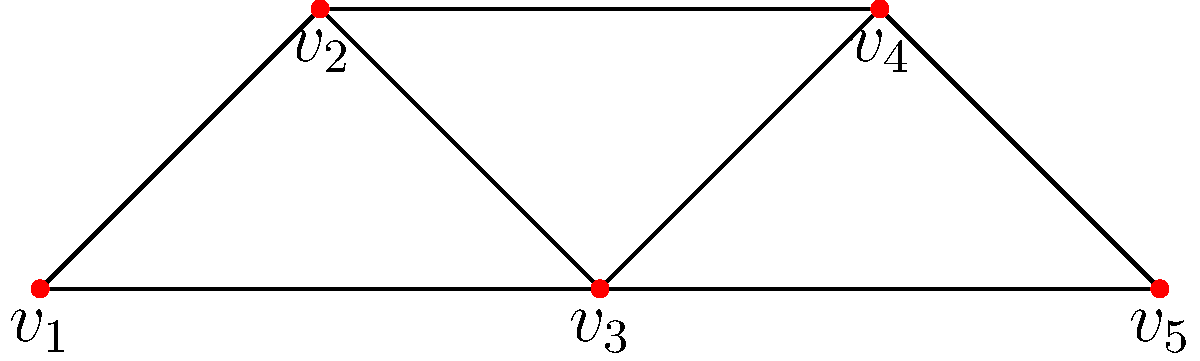Given the graph shown above, what is the minimum number of colors needed to color the vertices such that no two adjacent vertices have the same color? Provide your answer and explain the coloring strategy. To solve this problem, we'll use the greedy coloring algorithm:

1) Start with vertex $v_1$. Assign it color 1.

2) Move to $v_2$. It's adjacent to $v_1$, so we need a new color. Assign it color 2.

3) For $v_3$:
   - It's adjacent to $v_1$ (color 1) and $v_2$ (color 2).
   - We need a new color. Assign it color 3.

4) For $v_4$:
   - It's adjacent to $v_2$ (color 2) and $v_3$ (color 3).
   - We can use color 1.

5) For $v_5$:
   - It's adjacent to $v_3$ (color 3) and $v_4$ (color 1).
   - We can use color 2.

Therefore, we've colored the graph using 3 colors:
- Color 1: $v_1$, $v_4$
- Color 2: $v_2$, $v_5$
- Color 3: $v_3$

This is the minimum number of colors needed because the graph contains a triangle ($v_1$, $v_2$, $v_3$), which requires at least 3 colors.
Answer: 3 colors 